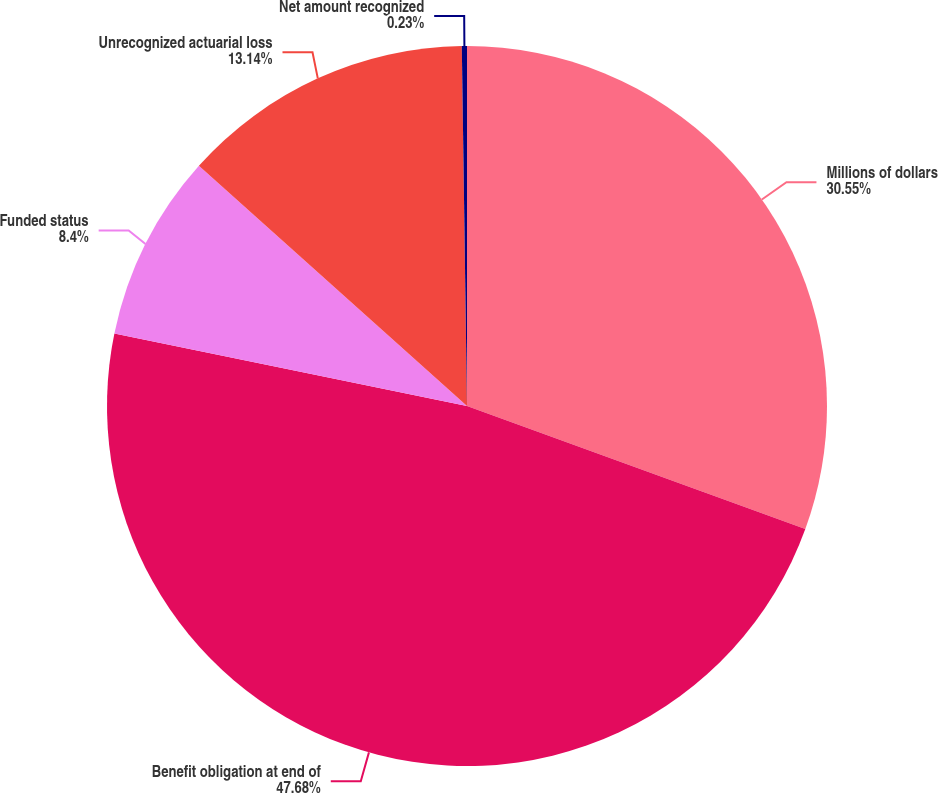Convert chart. <chart><loc_0><loc_0><loc_500><loc_500><pie_chart><fcel>Millions of dollars<fcel>Benefit obligation at end of<fcel>Funded status<fcel>Unrecognized actuarial loss<fcel>Net amount recognized<nl><fcel>30.55%<fcel>47.67%<fcel>8.4%<fcel>13.14%<fcel>0.23%<nl></chart> 